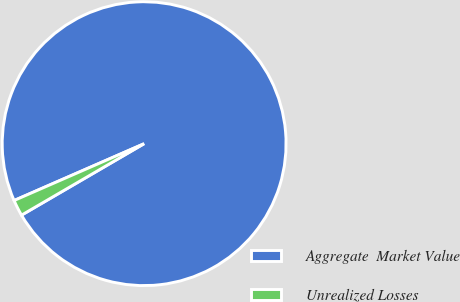Convert chart to OTSL. <chart><loc_0><loc_0><loc_500><loc_500><pie_chart><fcel>Aggregate  Market Value<fcel>Unrealized Losses<nl><fcel>98.16%<fcel>1.84%<nl></chart> 